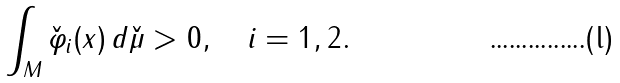<formula> <loc_0><loc_0><loc_500><loc_500>\int _ { M } { \check { \varphi } } _ { i } ( x ) \, d { \check { \mu } } > 0 , \quad i = 1 , 2 .</formula> 